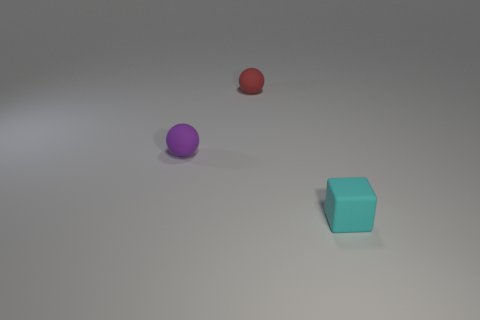Add 3 purple balls. How many objects exist? 6 Subtract all spheres. How many objects are left? 1 Add 1 matte things. How many matte things are left? 4 Add 2 rubber things. How many rubber things exist? 5 Subtract 0 gray cylinders. How many objects are left? 3 Subtract all tiny yellow metal spheres. Subtract all tiny cyan things. How many objects are left? 2 